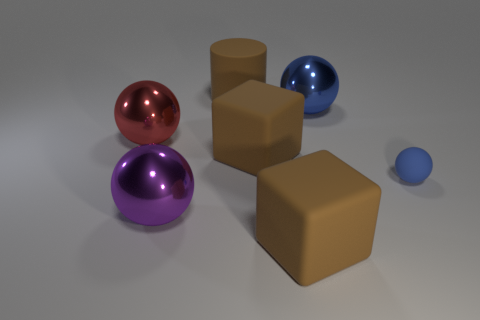Add 2 big blue metallic objects. How many objects exist? 9 Subtract all spheres. How many objects are left? 3 Subtract all big red shiny things. Subtract all red metallic balls. How many objects are left? 5 Add 3 large blue metallic things. How many large blue metallic things are left? 4 Add 1 large brown cubes. How many large brown cubes exist? 3 Subtract 0 cyan cylinders. How many objects are left? 7 